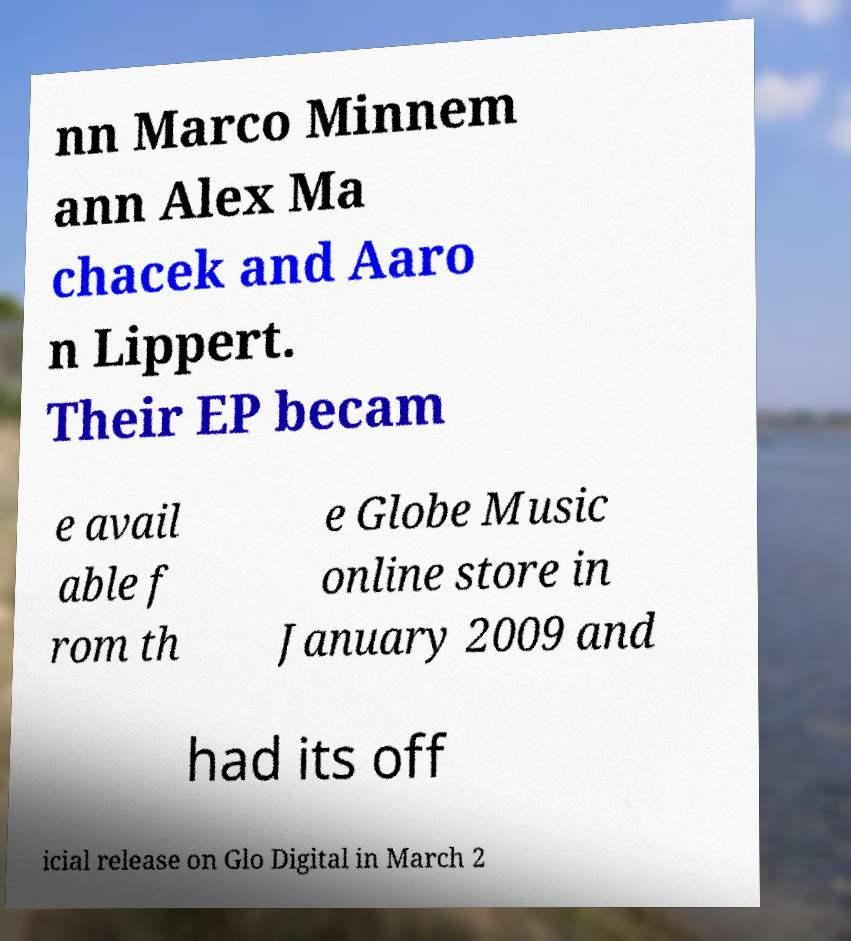Please read and relay the text visible in this image. What does it say? nn Marco Minnem ann Alex Ma chacek and Aaro n Lippert. Their EP becam e avail able f rom th e Globe Music online store in January 2009 and had its off icial release on Glo Digital in March 2 